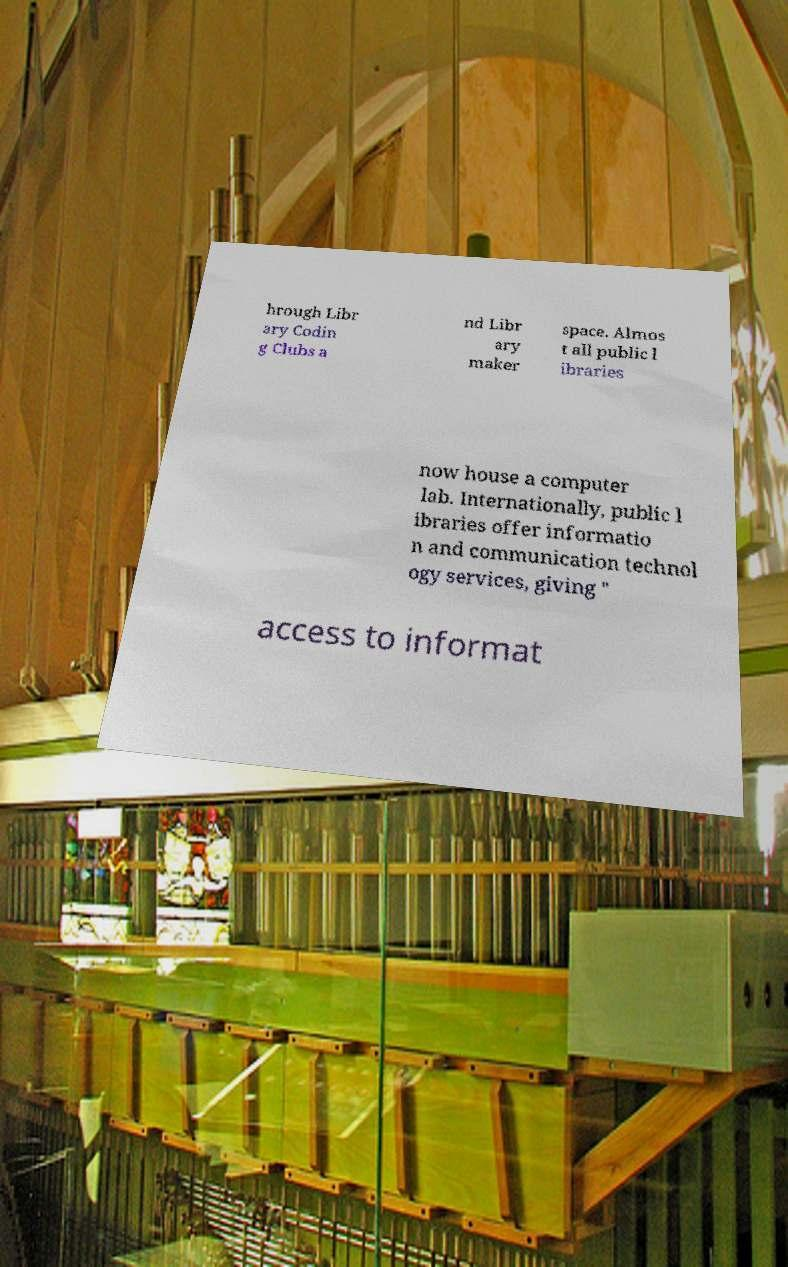Can you accurately transcribe the text from the provided image for me? hrough Libr ary Codin g Clubs a nd Libr ary maker space. Almos t all public l ibraries now house a computer lab. Internationally, public l ibraries offer informatio n and communication technol ogy services, giving " access to informat 